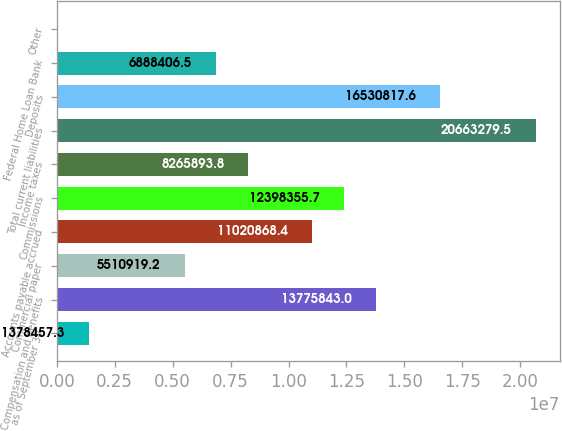Convert chart. <chart><loc_0><loc_0><loc_500><loc_500><bar_chart><fcel>as of September 30<fcel>Compensation and benefits<fcel>Commercial paper<fcel>Accounts payable accrued<fcel>Commissions<fcel>Income taxes<fcel>Total current liabilities<fcel>Deposits<fcel>Federal Home Loan Bank<fcel>Other<nl><fcel>1.37846e+06<fcel>1.37758e+07<fcel>5.51092e+06<fcel>1.10209e+07<fcel>1.23984e+07<fcel>8.26589e+06<fcel>2.06633e+07<fcel>1.65308e+07<fcel>6.88841e+06<fcel>970<nl></chart> 